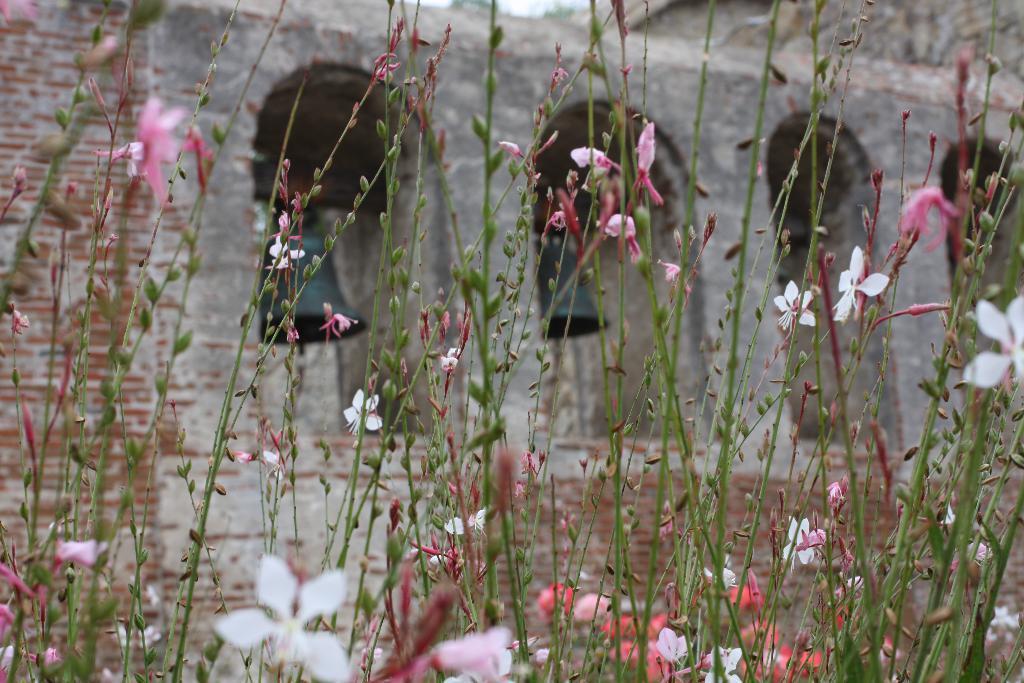In one or two sentences, can you explain what this image depicts? In this image we can see some plants with flowers and buds on it, in the background we can see a building. 